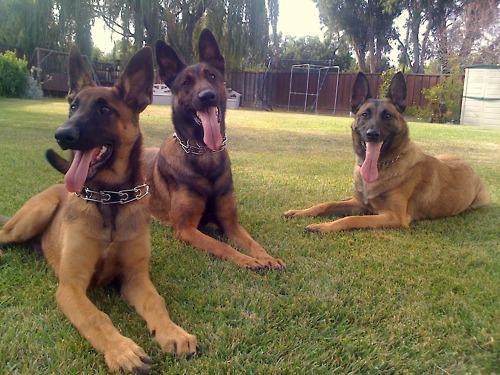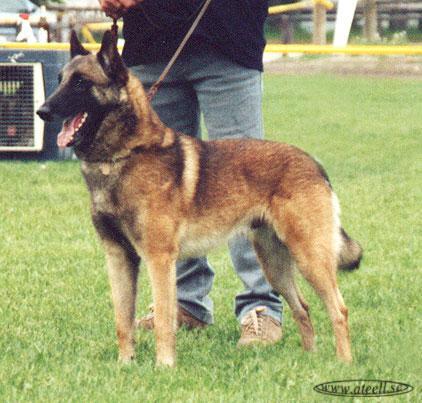The first image is the image on the left, the second image is the image on the right. Examine the images to the left and right. Is the description "There are at most four dogs." accurate? Answer yes or no. Yes. The first image is the image on the left, the second image is the image on the right. Evaluate the accuracy of this statement regarding the images: "The left image includes three german shepherds with tongues out, in reclining poses with front paws extended and flat on the ground.". Is it true? Answer yes or no. Yes. 